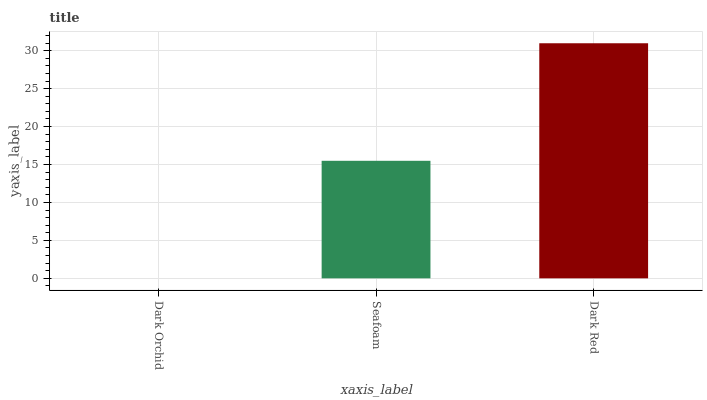Is Dark Orchid the minimum?
Answer yes or no. Yes. Is Dark Red the maximum?
Answer yes or no. Yes. Is Seafoam the minimum?
Answer yes or no. No. Is Seafoam the maximum?
Answer yes or no. No. Is Seafoam greater than Dark Orchid?
Answer yes or no. Yes. Is Dark Orchid less than Seafoam?
Answer yes or no. Yes. Is Dark Orchid greater than Seafoam?
Answer yes or no. No. Is Seafoam less than Dark Orchid?
Answer yes or no. No. Is Seafoam the high median?
Answer yes or no. Yes. Is Seafoam the low median?
Answer yes or no. Yes. Is Dark Orchid the high median?
Answer yes or no. No. Is Dark Red the low median?
Answer yes or no. No. 